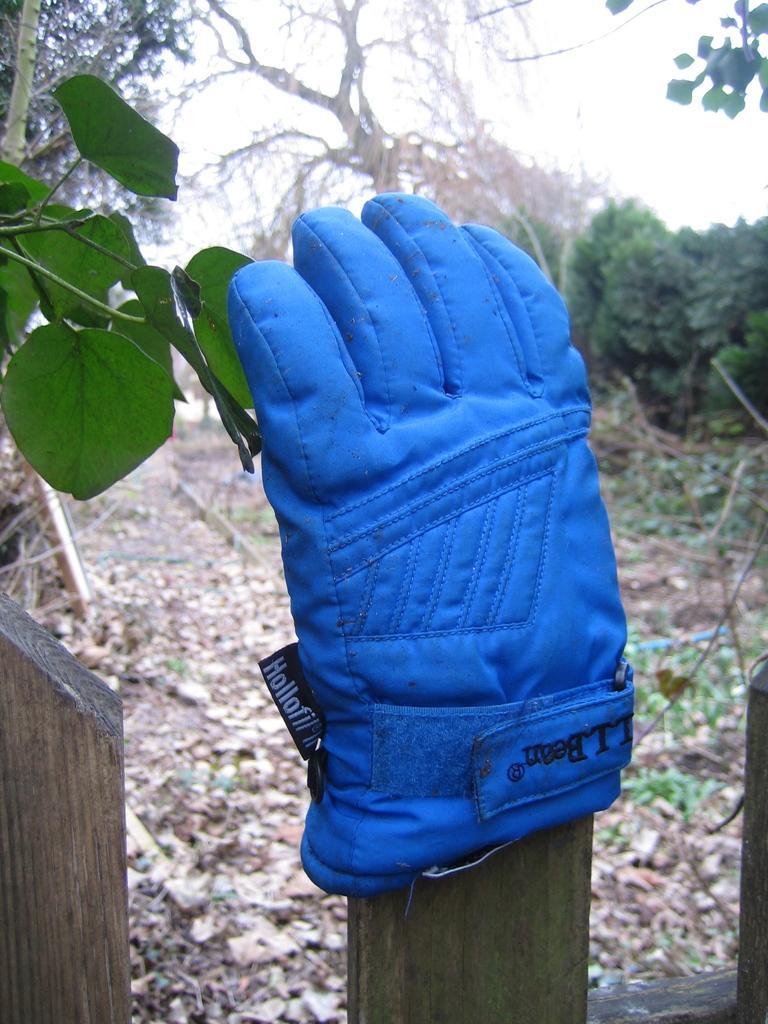Can you describe this image briefly? In the picture there is a small branch of a plant and there is a fencing beside the plant and to one of the fencing pole there is a blue glove,in the background there are many dry trees and on the ground there are plenty of dry leaves. 